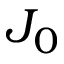Convert formula to latex. <formula><loc_0><loc_0><loc_500><loc_500>J _ { 0 }</formula> 